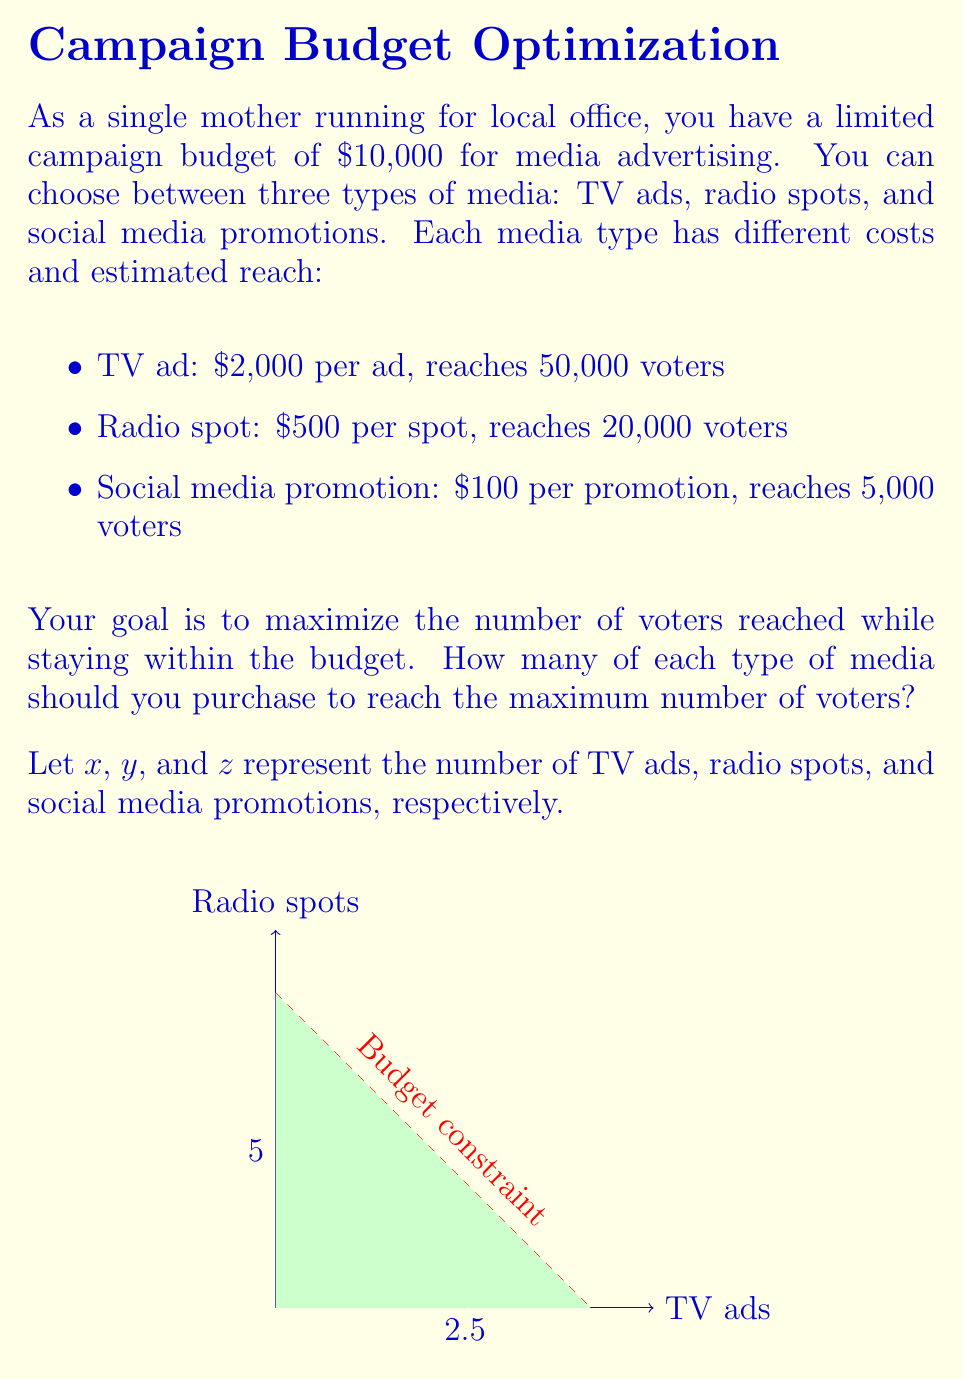Teach me how to tackle this problem. Let's approach this step-by-step using linear programming:

1) Define the objective function:
   Maximize: $50000x + 20000y + 5000z$

2) Set up the constraints:
   Budget constraint: $2000x + 500y + 100z \leq 10000$
   Non-negativity: $x, y, z \geq 0$ and integer

3) Simplify the budget constraint:
   $20x + 5y + z \leq 100$

4) We can solve this using the simplex method, but let's use a more intuitive approach:

   a) Notice that TV ads and radio spots have the same efficiency (25 voters/$):
      TV: 50000/2000 = 25 voters/$
      Radio: 20000/500 = 25 voters/$
   
   b) Social media is more efficient: 5000/100 = 50 voters/$

5) Therefore, we should allocate as much budget as possible to social media:
   Maximum social media promotions: $\lfloor 10000/100 \rfloor = 100$

6) This uses the entire budget, so our solution is:
   $x = 0, y = 0, z = 100$

7) Total reach: $100 * 5000 = 500,000$ voters

This solution maximizes the number of voters reached within the given budget.
Answer: 0 TV ads, 0 radio spots, 100 social media promotions 